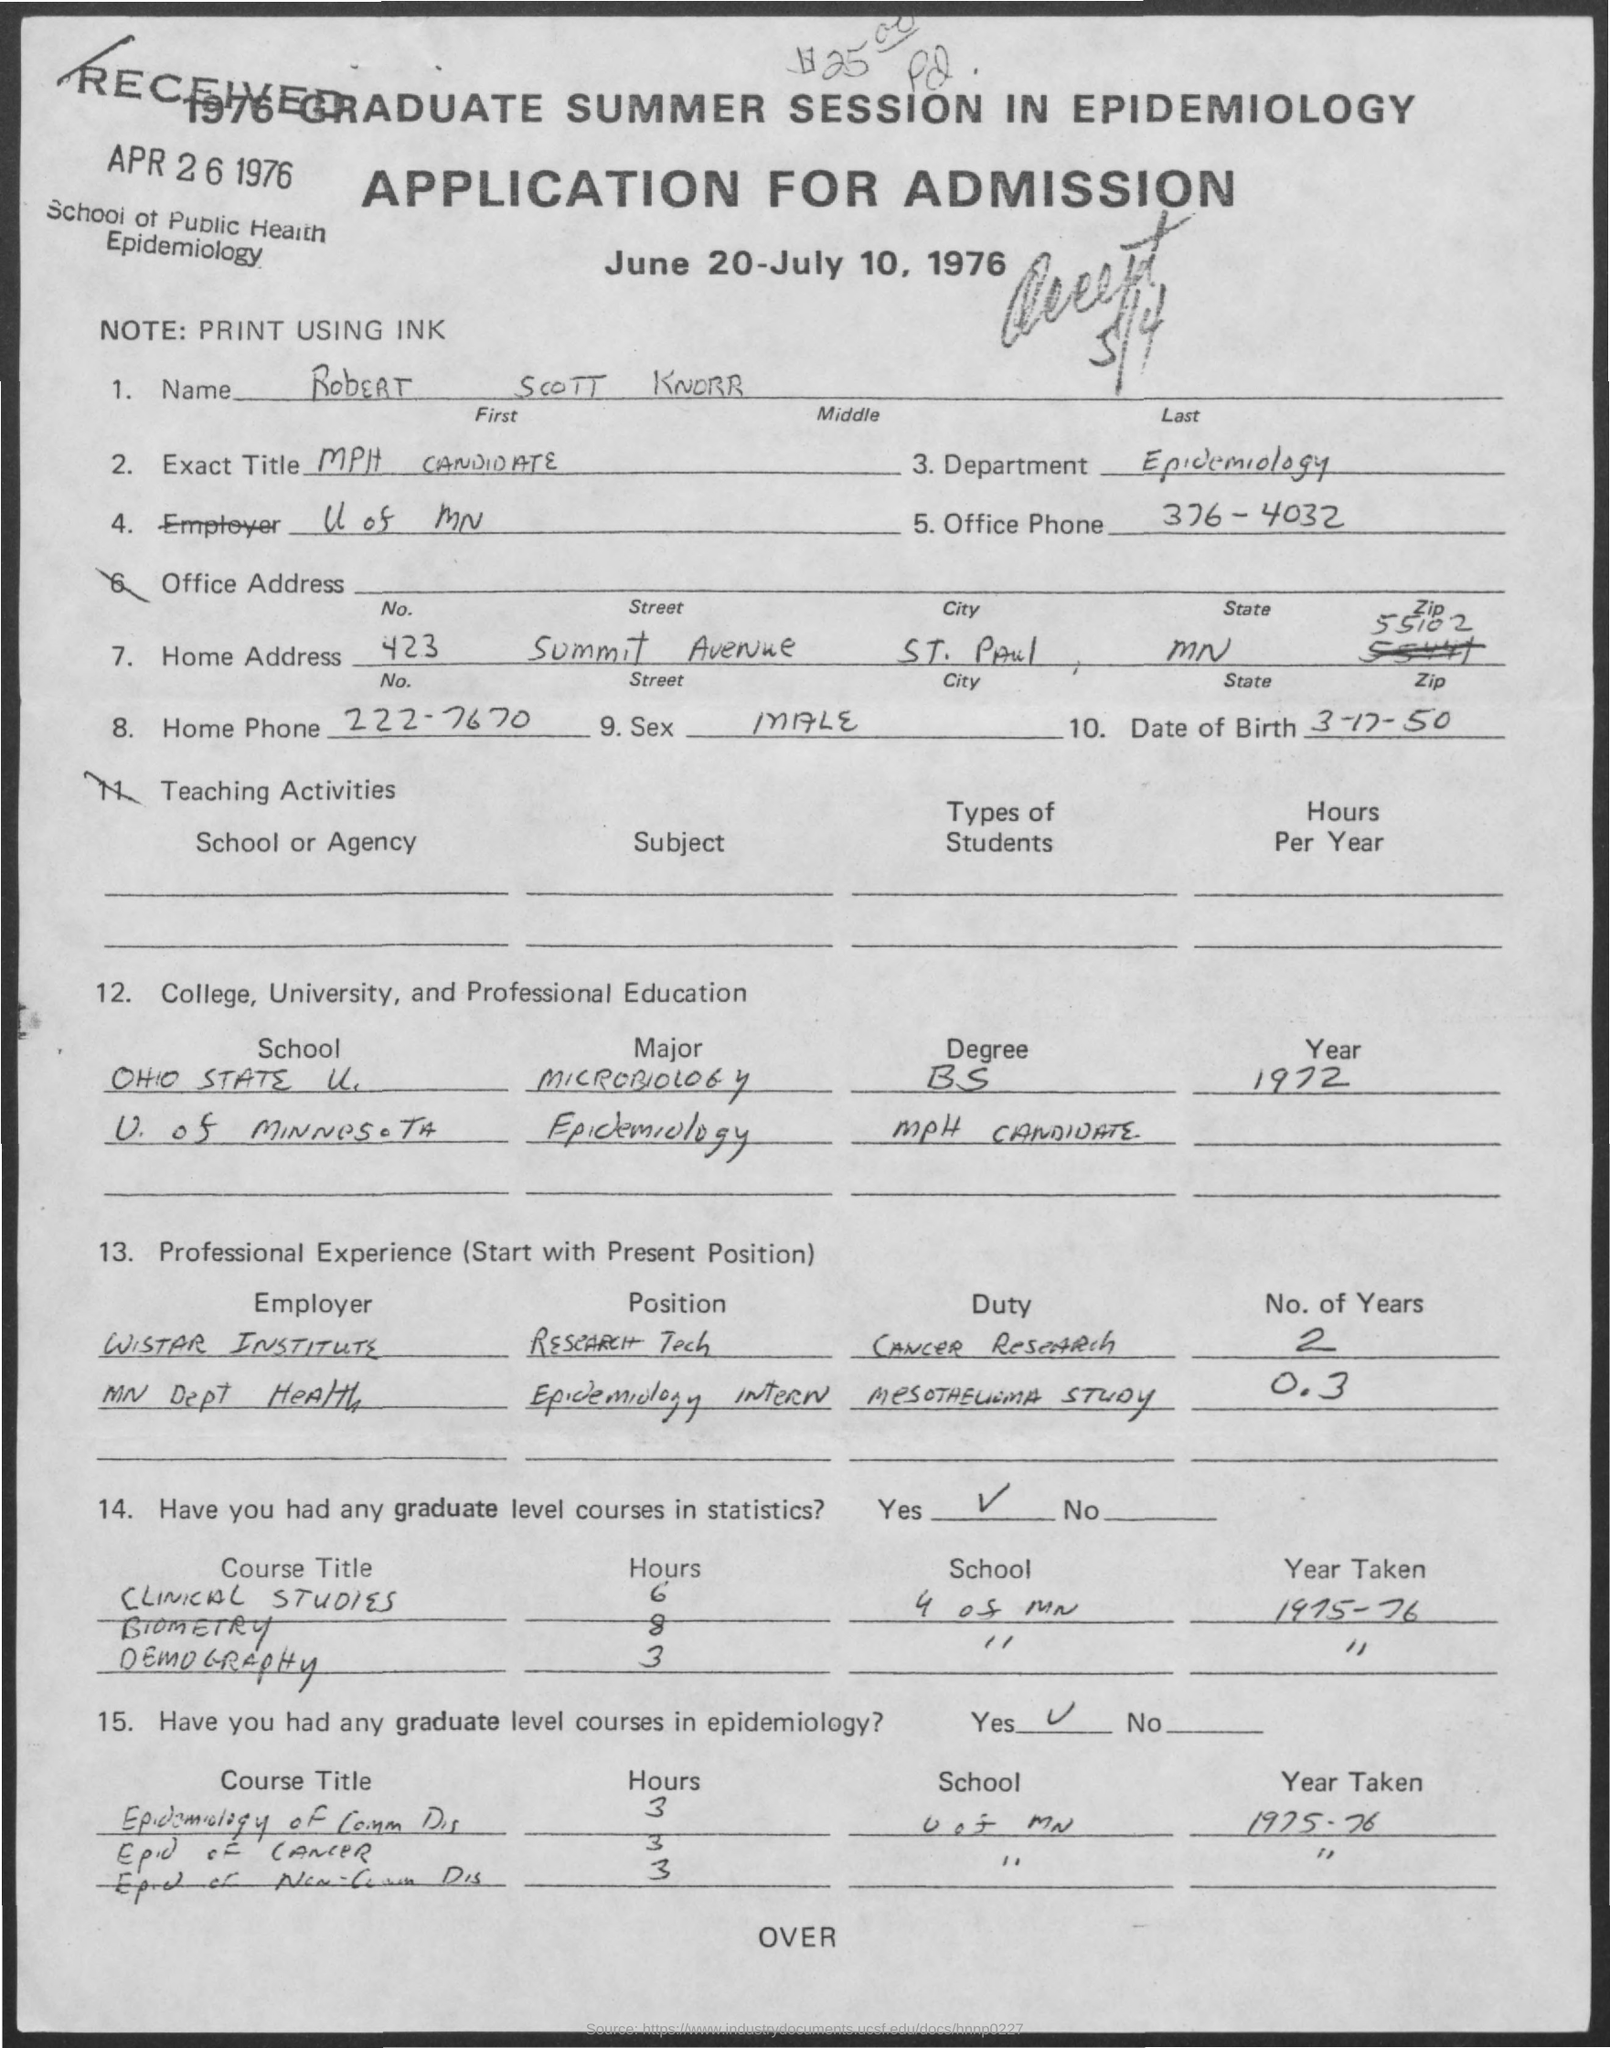Outline some significant characteristics in this image. The office phone number mentioned in the application is 376-4032. Robert Scott Knorr was assigned the duty of conducting cancer research as a Research Technician at the Wistar Institute. Please indicate the postal code specified in the application, which is 55102... Robert Scott Knorr completed his Bachelor of Science degree in Microbiology in the year 1972. The date of birth of Robert Scott Knorr is March 17, 1950. 